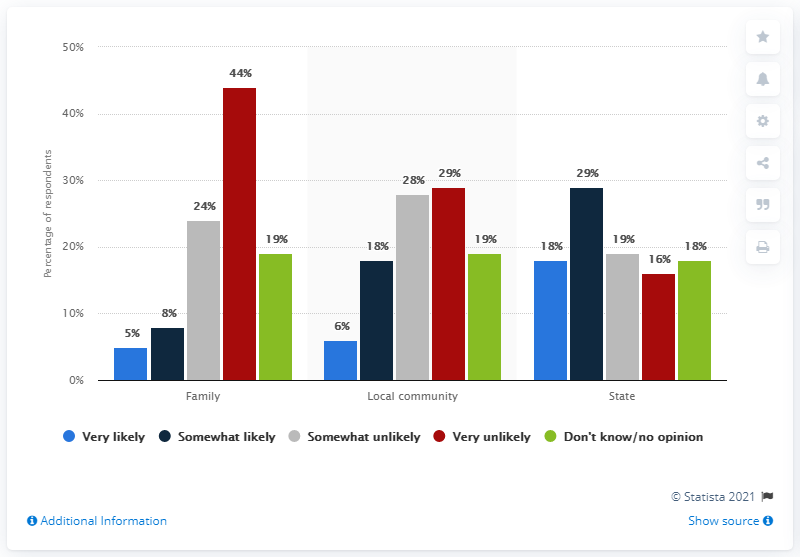Point out several critical features in this image. The likelihood of the new coronavirus affecting only families in the U.S. as of January 2020 was assessed to be approximately 5%. The likelihood of the new coronavirus affecting families and communities in the U.S. as of January 2020 was assessed to be very likely, with a total percentage of 11%. 